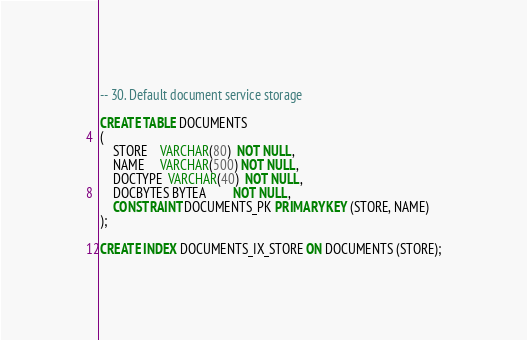Convert code to text. <code><loc_0><loc_0><loc_500><loc_500><_SQL_>-- 30. Default document service storage

CREATE TABLE DOCUMENTS
(
    STORE    VARCHAR(80)  NOT NULL,
    NAME     VARCHAR(500) NOT NULL,
    DOCTYPE  VARCHAR(40)  NOT NULL,
    DOCBYTES BYTEA        NOT NULL,
    CONSTRAINT DOCUMENTS_PK PRIMARY KEY (STORE, NAME)
);

CREATE INDEX DOCUMENTS_IX_STORE ON DOCUMENTS (STORE);
</code> 